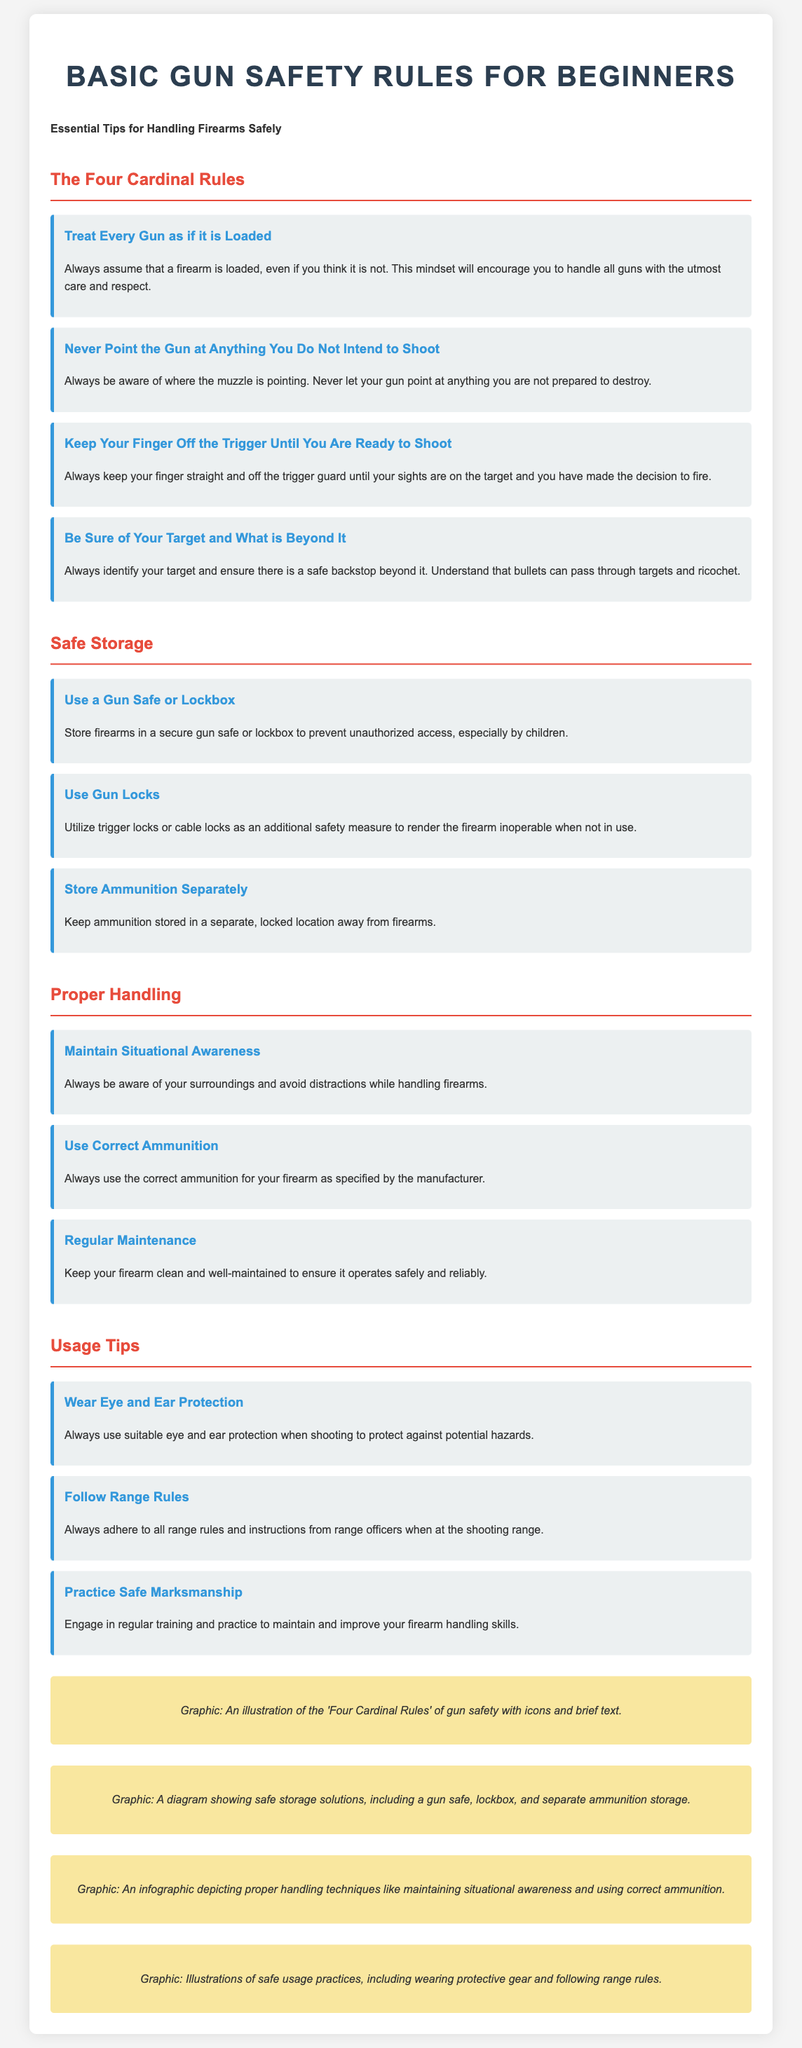What are the Four Cardinal Rules? The Four Cardinal Rules are the main principles that guide safe gun handling, outlined in the flyer in a dedicated section.
Answer: Treat Every Gun as if it is Loaded, Never Point the Gun at Anything You Do Not Intend to Shoot, Keep Your Finger Off the Trigger Until You Are Ready to Shoot, Be Sure of Your Target and What is Beyond It What is recommended for safe storage of firearms? The flyer highlights specific tips for safe storage under a dedicated section, citing methods to reduce unauthorized access.
Answer: Use a Gun Safe or Lockbox What should you wear when shooting? The flyer includes specific safety gear recommendations under the usage tips section.
Answer: Eye and Ear Protection How many tips are provided for Proper Handling? This requires counting the tips listed under the Proper Handling section of the flyer.
Answer: Three What is an important aspect of Regular Maintenance? Regular Maintenance emphasizes the importance of keeping the firearm in working order.
Answer: Keep your firearm clean and well-maintained What is the main purpose of using trigger locks? The flyer discusses the use of trigger locks in the Safe Storage section, detailing their primary function.
Answer: To render the firearm inoperable when not in use Why should ammunition be stored separately? The flyer mentions reasons for storing ammunition away from firearms in the Safe Storage section.
Answer: To prevent unauthorized access, especially by children What graphic is included to illustrate gun storage solutions? There is a specific visual component mentioned that represents safe storage practices.
Answer: A diagram showing safe storage solutions, including a gun safe, lockbox, and separate ammunition storage 